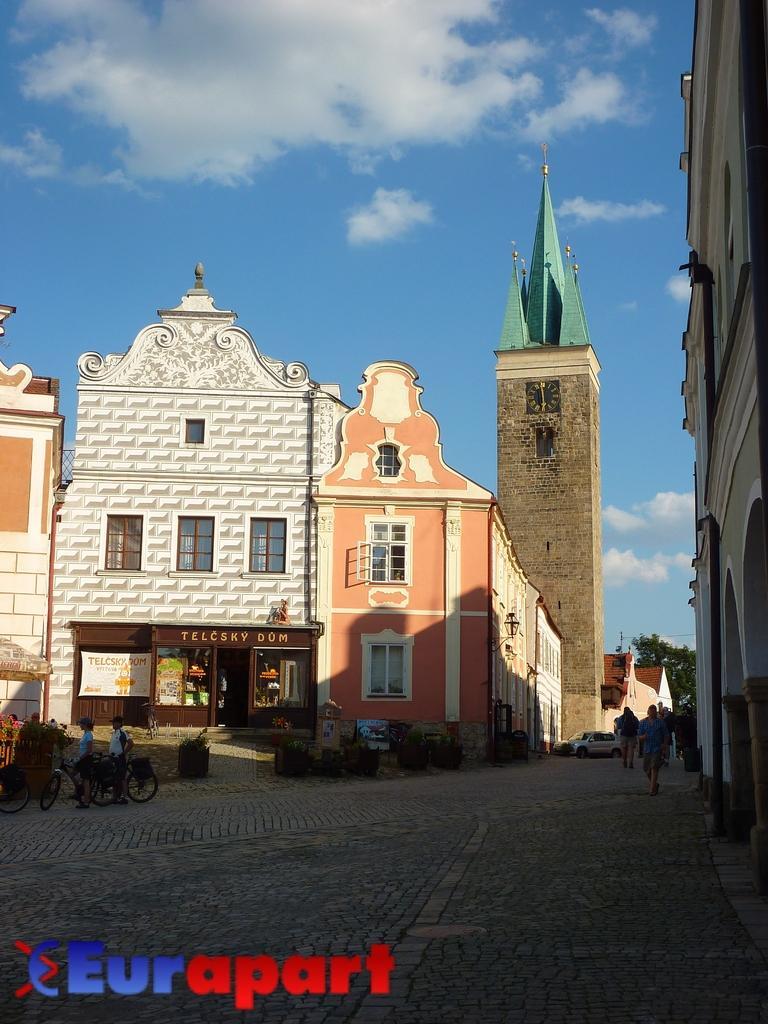Describe this image in one or two sentences. In this image we can see a few buildings, there are some vehicles, trees, people and potted plants, in the background, we can see the sky with clouds, at the bottom of the image we can see the text. 